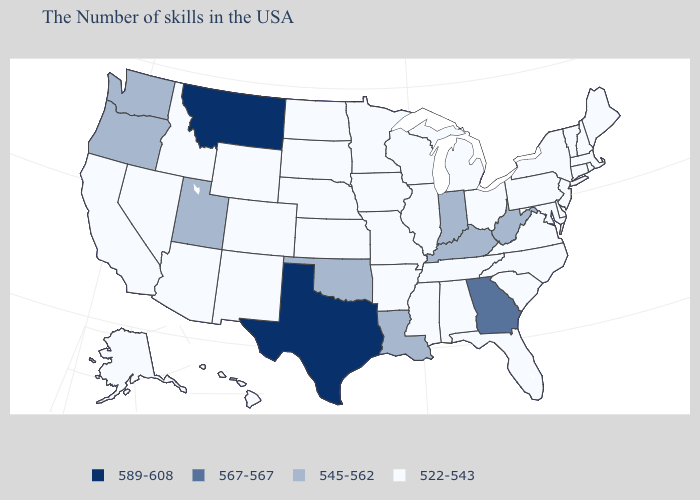What is the value of New York?
Short answer required. 522-543. Name the states that have a value in the range 567-567?
Short answer required. Georgia. What is the highest value in the USA?
Concise answer only. 589-608. Name the states that have a value in the range 567-567?
Quick response, please. Georgia. Name the states that have a value in the range 545-562?
Quick response, please. West Virginia, Kentucky, Indiana, Louisiana, Oklahoma, Utah, Washington, Oregon. Which states have the lowest value in the Northeast?
Short answer required. Maine, Massachusetts, Rhode Island, New Hampshire, Vermont, Connecticut, New York, New Jersey, Pennsylvania. Name the states that have a value in the range 589-608?
Concise answer only. Texas, Montana. What is the highest value in the MidWest ?
Give a very brief answer. 545-562. Does Utah have the lowest value in the USA?
Concise answer only. No. What is the value of South Carolina?
Write a very short answer. 522-543. Does Washington have a higher value than Montana?
Short answer required. No. What is the value of Vermont?
Keep it brief. 522-543. What is the highest value in the South ?
Answer briefly. 589-608. Name the states that have a value in the range 545-562?
Be succinct. West Virginia, Kentucky, Indiana, Louisiana, Oklahoma, Utah, Washington, Oregon. 